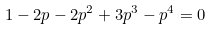Convert formula to latex. <formula><loc_0><loc_0><loc_500><loc_500>1 - 2 p - 2 p ^ { 2 } + 3 p ^ { 3 } - p ^ { 4 } = 0</formula> 